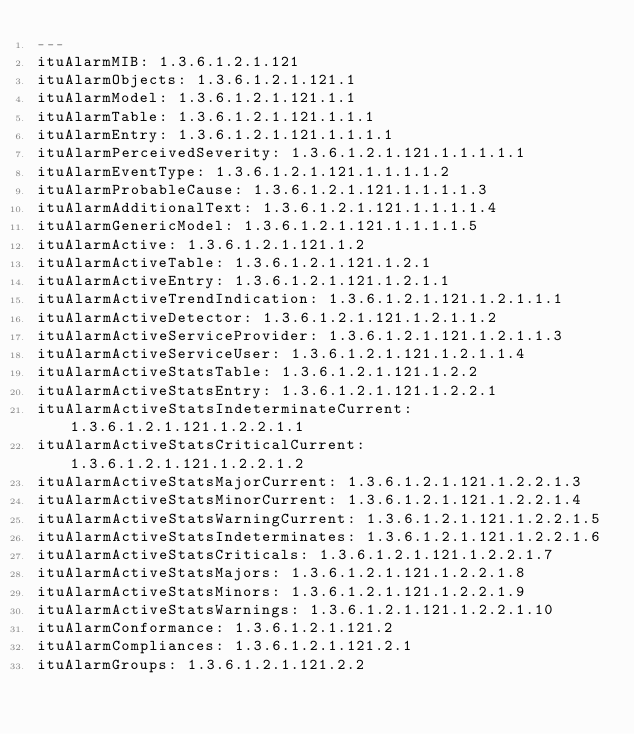Convert code to text. <code><loc_0><loc_0><loc_500><loc_500><_YAML_>--- 
ituAlarmMIB: 1.3.6.1.2.1.121
ituAlarmObjects: 1.3.6.1.2.1.121.1
ituAlarmModel: 1.3.6.1.2.1.121.1.1
ituAlarmTable: 1.3.6.1.2.1.121.1.1.1
ituAlarmEntry: 1.3.6.1.2.1.121.1.1.1.1
ituAlarmPerceivedSeverity: 1.3.6.1.2.1.121.1.1.1.1.1
ituAlarmEventType: 1.3.6.1.2.1.121.1.1.1.1.2
ituAlarmProbableCause: 1.3.6.1.2.1.121.1.1.1.1.3
ituAlarmAdditionalText: 1.3.6.1.2.1.121.1.1.1.1.4
ituAlarmGenericModel: 1.3.6.1.2.1.121.1.1.1.1.5
ituAlarmActive: 1.3.6.1.2.1.121.1.2
ituAlarmActiveTable: 1.3.6.1.2.1.121.1.2.1
ituAlarmActiveEntry: 1.3.6.1.2.1.121.1.2.1.1
ituAlarmActiveTrendIndication: 1.3.6.1.2.1.121.1.2.1.1.1
ituAlarmActiveDetector: 1.3.6.1.2.1.121.1.2.1.1.2
ituAlarmActiveServiceProvider: 1.3.6.1.2.1.121.1.2.1.1.3
ituAlarmActiveServiceUser: 1.3.6.1.2.1.121.1.2.1.1.4
ituAlarmActiveStatsTable: 1.3.6.1.2.1.121.1.2.2
ituAlarmActiveStatsEntry: 1.3.6.1.2.1.121.1.2.2.1
ituAlarmActiveStatsIndeterminateCurrent: 1.3.6.1.2.1.121.1.2.2.1.1
ituAlarmActiveStatsCriticalCurrent: 1.3.6.1.2.1.121.1.2.2.1.2
ituAlarmActiveStatsMajorCurrent: 1.3.6.1.2.1.121.1.2.2.1.3
ituAlarmActiveStatsMinorCurrent: 1.3.6.1.2.1.121.1.2.2.1.4
ituAlarmActiveStatsWarningCurrent: 1.3.6.1.2.1.121.1.2.2.1.5
ituAlarmActiveStatsIndeterminates: 1.3.6.1.2.1.121.1.2.2.1.6
ituAlarmActiveStatsCriticals: 1.3.6.1.2.1.121.1.2.2.1.7
ituAlarmActiveStatsMajors: 1.3.6.1.2.1.121.1.2.2.1.8
ituAlarmActiveStatsMinors: 1.3.6.1.2.1.121.1.2.2.1.9
ituAlarmActiveStatsWarnings: 1.3.6.1.2.1.121.1.2.2.1.10
ituAlarmConformance: 1.3.6.1.2.1.121.2
ituAlarmCompliances: 1.3.6.1.2.1.121.2.1
ituAlarmGroups: 1.3.6.1.2.1.121.2.2

</code> 